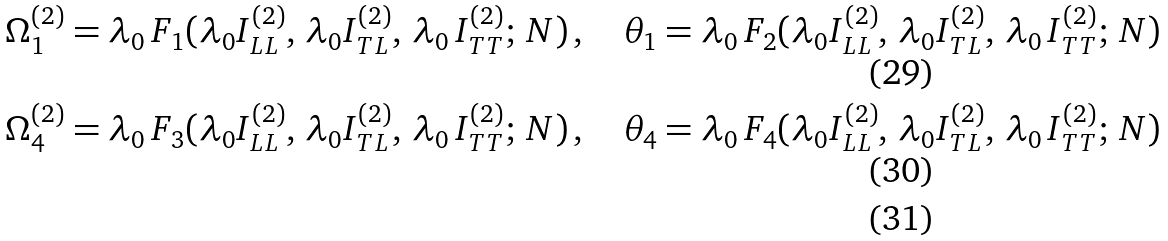<formula> <loc_0><loc_0><loc_500><loc_500>& \Omega ^ { ( 2 ) } _ { 1 } = \lambda _ { 0 } \, F _ { 1 } ( \lambda _ { 0 } I _ { L L } ^ { ( 2 ) } , \, \lambda _ { 0 } I _ { T L } ^ { ( 2 ) } , \, \lambda _ { 0 } \, I _ { T T } ^ { ( 2 ) } ; \, N ) \, , \quad \theta _ { 1 } = \lambda _ { 0 } \, F _ { 2 } ( \lambda _ { 0 } I _ { L L } ^ { ( 2 ) } , \, \lambda _ { 0 } I _ { T L } ^ { ( 2 ) } , \, \lambda _ { 0 } \, I _ { T T } ^ { ( 2 ) } ; \, N ) \\ & \Omega ^ { ( 2 ) } _ { 4 } = \lambda _ { 0 } \, F _ { 3 } ( \lambda _ { 0 } I _ { L L } ^ { ( 2 ) } , \, \lambda _ { 0 } I _ { T L } ^ { ( 2 ) } , \, \lambda _ { 0 } \, I _ { T T } ^ { ( 2 ) } ; \, N ) \, , \quad \theta _ { 4 } = \lambda _ { 0 } \, F _ { 4 } ( \lambda _ { 0 } I _ { L L } ^ { ( 2 ) } , \, \lambda _ { 0 } I _ { T L } ^ { ( 2 ) } , \, \lambda _ { 0 } \, I _ { T T } ^ { ( 2 ) } ; \, N ) \\</formula> 